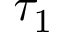<formula> <loc_0><loc_0><loc_500><loc_500>\tau _ { 1 }</formula> 